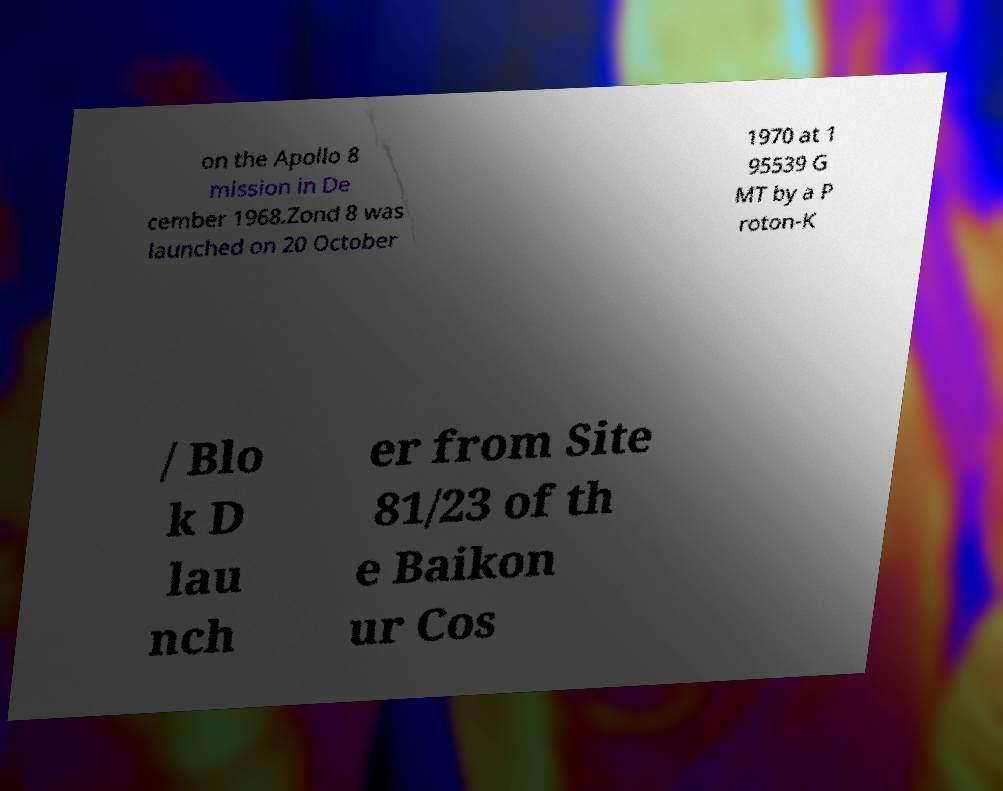Could you assist in decoding the text presented in this image and type it out clearly? on the Apollo 8 mission in De cember 1968.Zond 8 was launched on 20 October 1970 at 1 95539 G MT by a P roton-K / Blo k D lau nch er from Site 81/23 of th e Baikon ur Cos 